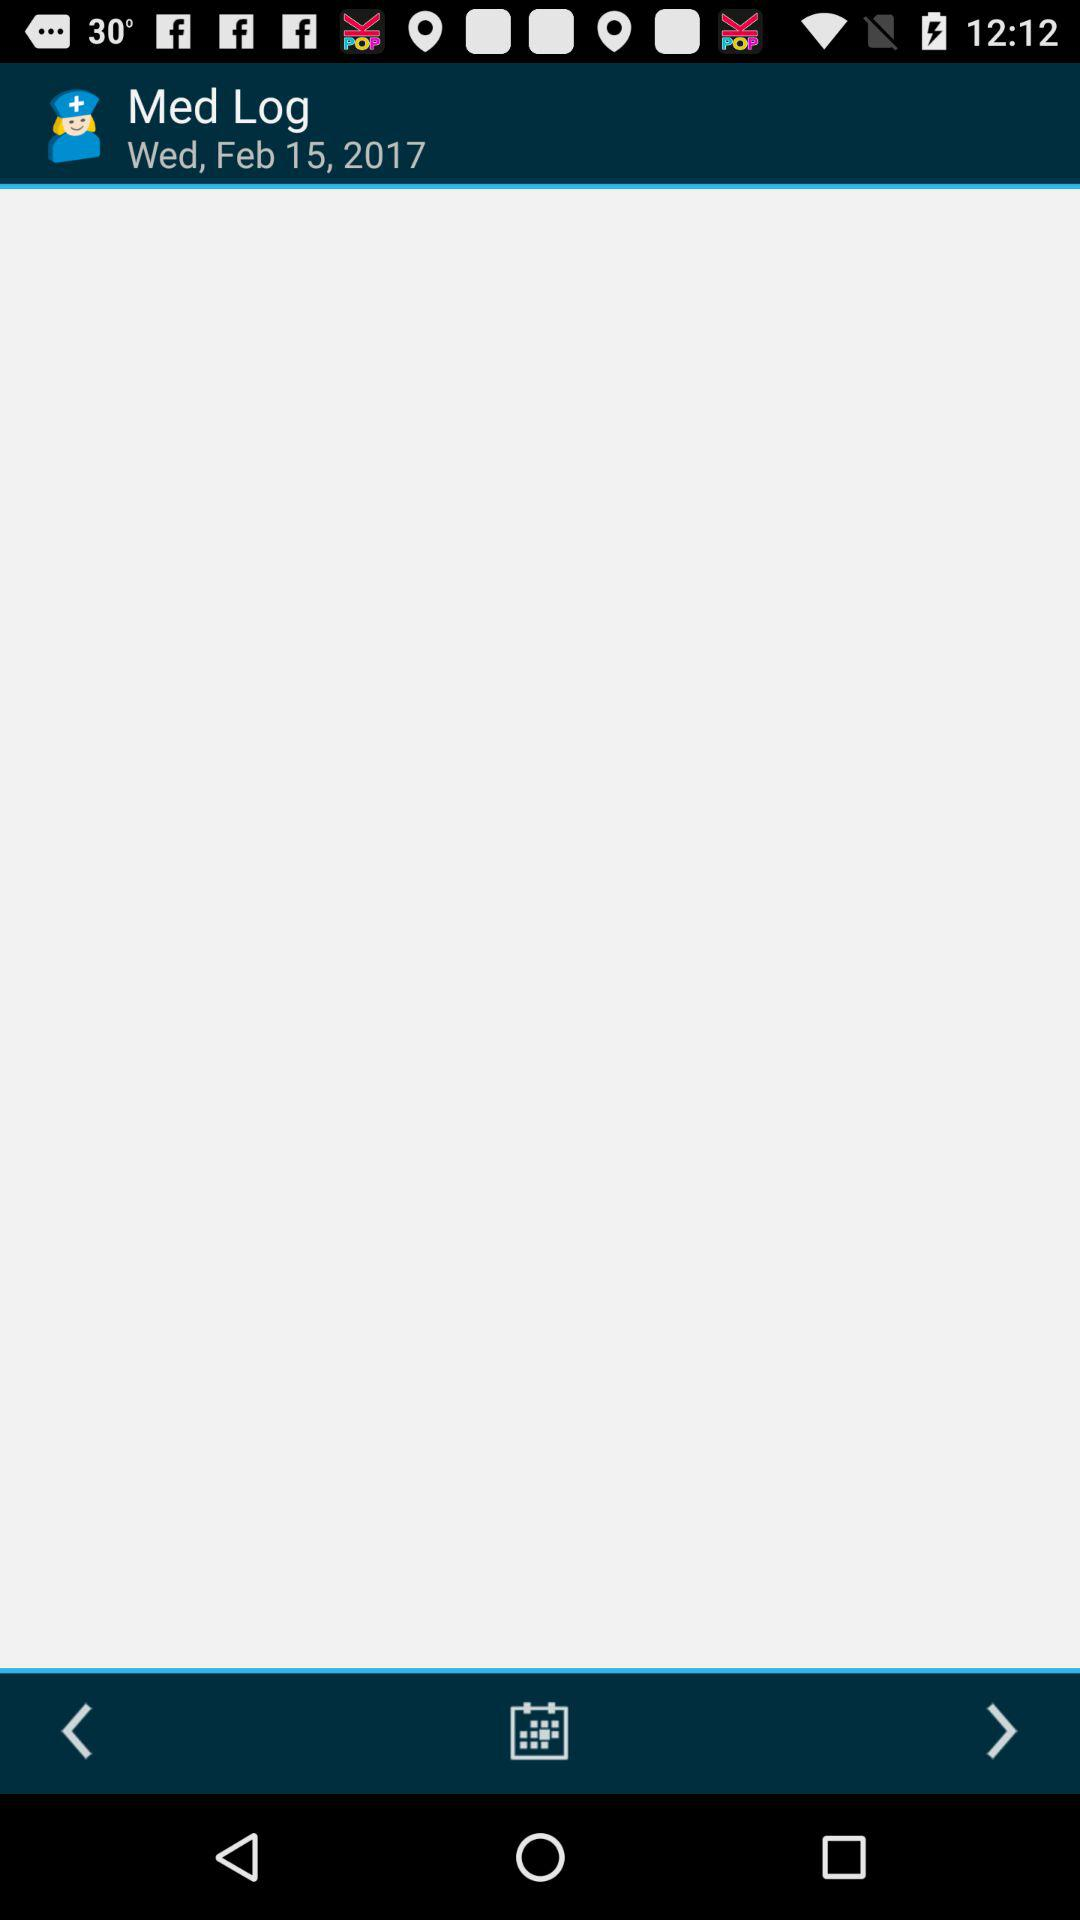What is the application name? The application name is "Med Helper Pro Pill Reminder". 